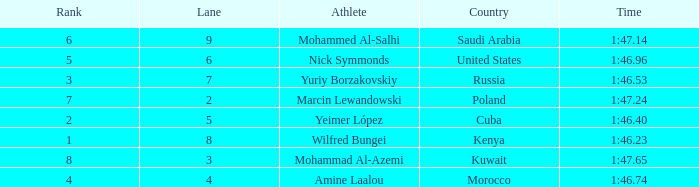What is the position of the athlete with a time of 1:4 None. 